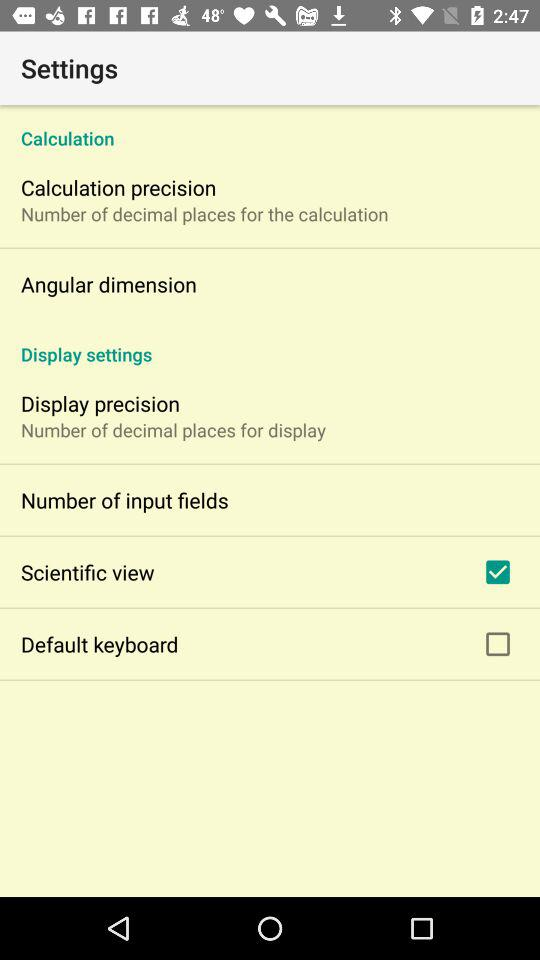How many items in the Display settings section have a checkbox?
Answer the question using a single word or phrase. 2 